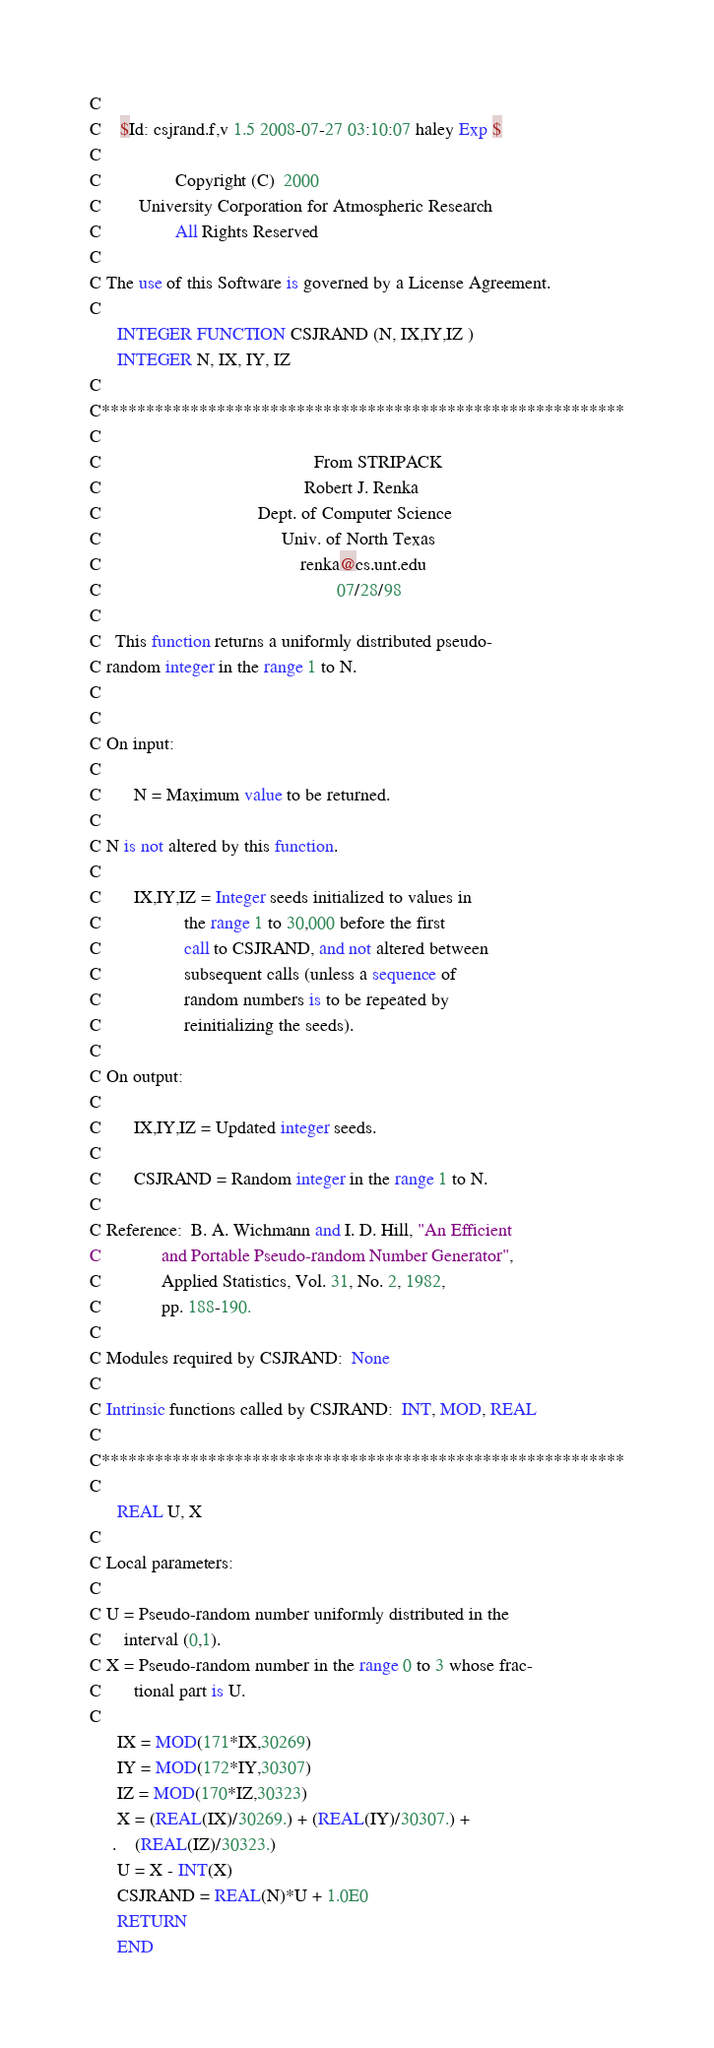Convert code to text. <code><loc_0><loc_0><loc_500><loc_500><_FORTRAN_>C
C	$Id: csjrand.f,v 1.5 2008-07-27 03:10:07 haley Exp $
C                                                                      
C                Copyright (C)  2000
C        University Corporation for Atmospheric Research
C                All Rights Reserved
C
C The use of this Software is governed by a License Agreement.
C
      INTEGER FUNCTION CSJRAND (N, IX,IY,IZ )
      INTEGER N, IX, IY, IZ
C
C***********************************************************
C
C                                              From STRIPACK
C                                            Robert J. Renka
C                                  Dept. of Computer Science
C                                       Univ. of North Texas
C                                           renka@cs.unt.edu
C                                                   07/28/98
C
C   This function returns a uniformly distributed pseudo-
C random integer in the range 1 to N.
C
C
C On input:
C
C       N = Maximum value to be returned.
C
C N is not altered by this function.
C
C       IX,IY,IZ = Integer seeds initialized to values in
C                  the range 1 to 30,000 before the first
C                  call to CSJRAND, and not altered between
C                  subsequent calls (unless a sequence of
C                  random numbers is to be repeated by
C                  reinitializing the seeds).
C
C On output:
C
C       IX,IY,IZ = Updated integer seeds.
C
C       CSJRAND = Random integer in the range 1 to N.
C
C Reference:  B. A. Wichmann and I. D. Hill, "An Efficient
C             and Portable Pseudo-random Number Generator",
C             Applied Statistics, Vol. 31, No. 2, 1982,
C             pp. 188-190.
C
C Modules required by CSJRAND:  None
C
C Intrinsic functions called by CSJRAND:  INT, MOD, REAL
C
C***********************************************************
C
      REAL U, X
C
C Local parameters:
C
C U = Pseudo-random number uniformly distributed in the
C     interval (0,1).
C X = Pseudo-random number in the range 0 to 3 whose frac-
C       tional part is U.
C
      IX = MOD(171*IX,30269)
      IY = MOD(172*IY,30307)
      IZ = MOD(170*IZ,30323)
      X = (REAL(IX)/30269.) + (REAL(IY)/30307.) +
     .    (REAL(IZ)/30323.)
      U = X - INT(X)
      CSJRAND = REAL(N)*U + 1.0E0
      RETURN
      END
</code> 